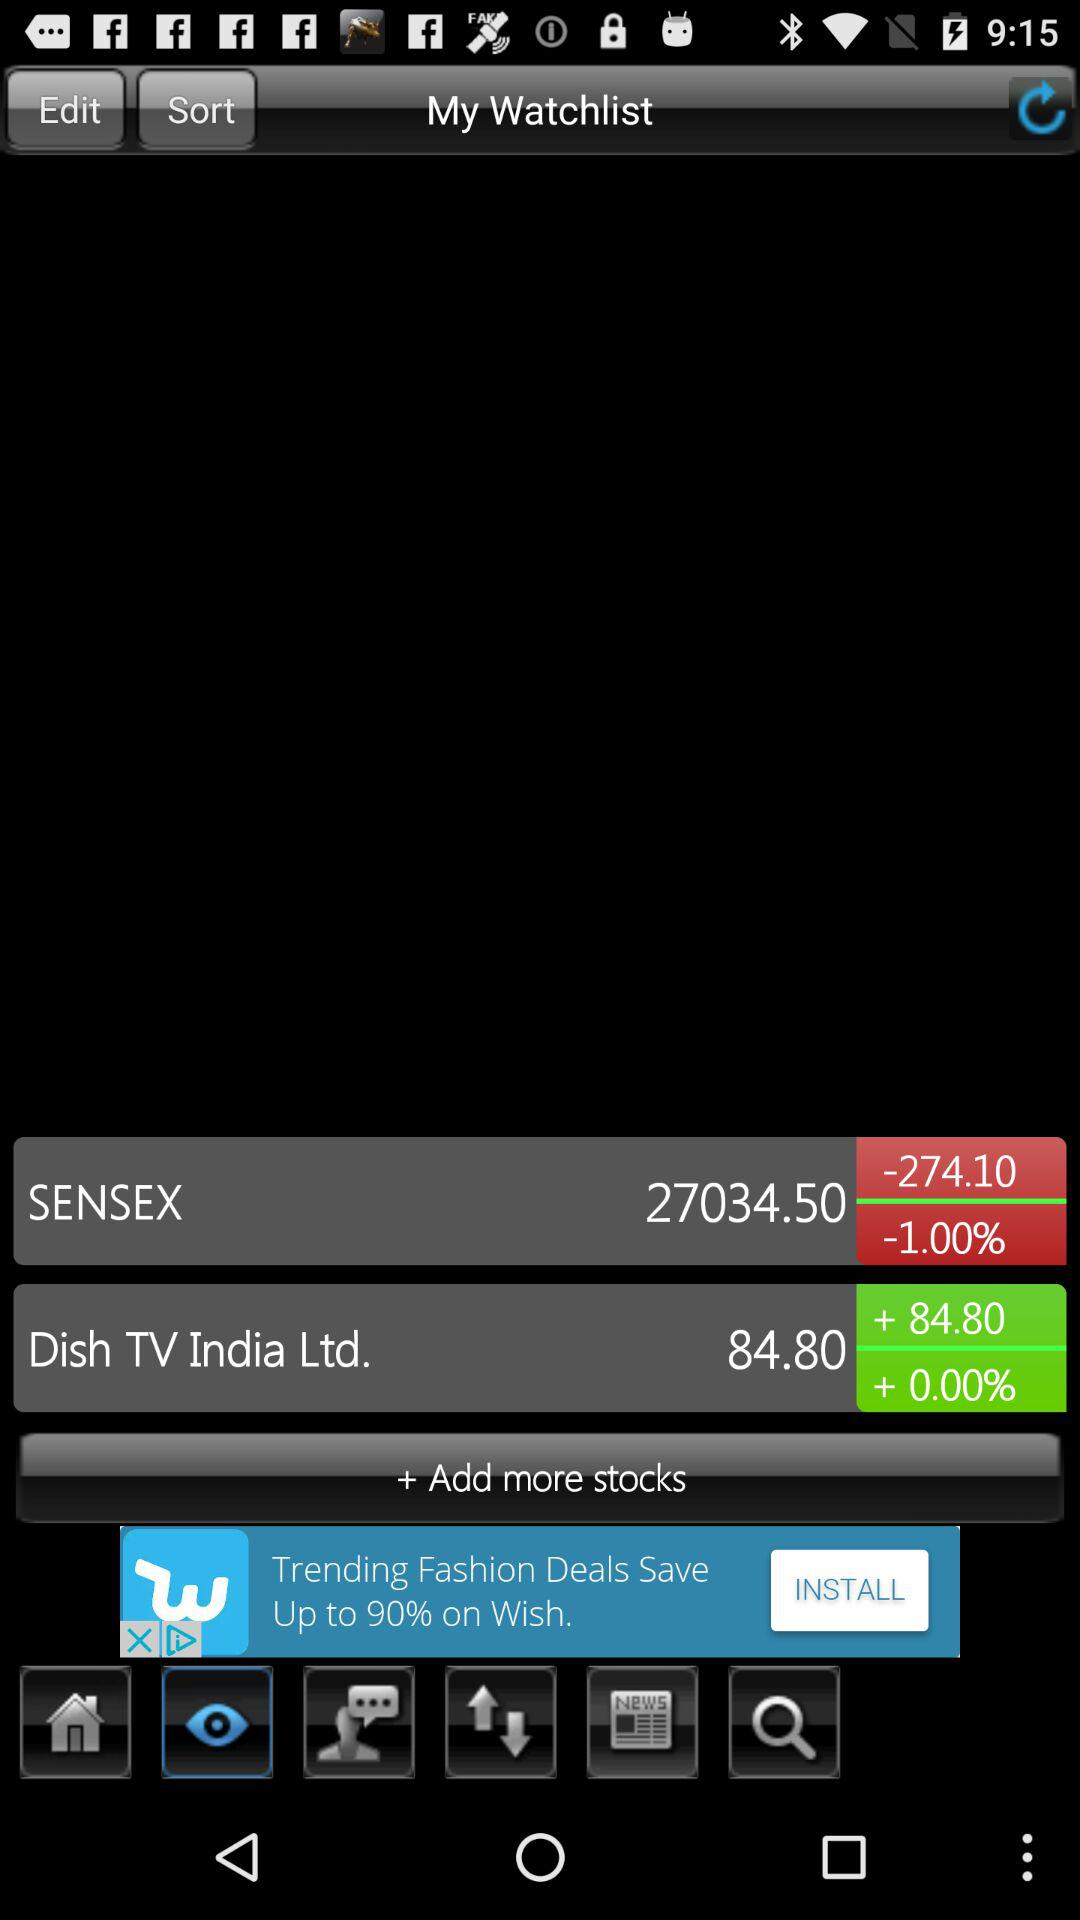What is the value of Dish TV India Ltd.'s stock? The value is 84.80. 